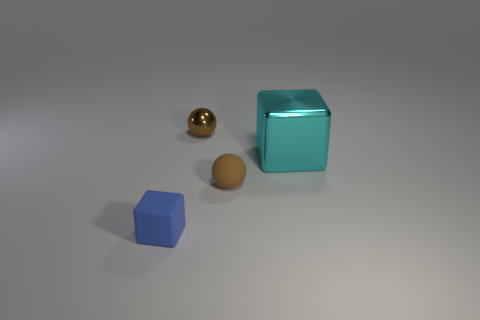Add 3 spheres. How many objects exist? 7 Subtract 0 purple balls. How many objects are left? 4 Subtract all blue matte cubes. Subtract all small blue matte things. How many objects are left? 2 Add 4 tiny brown balls. How many tiny brown balls are left? 6 Add 3 big brown metallic things. How many big brown metallic things exist? 3 